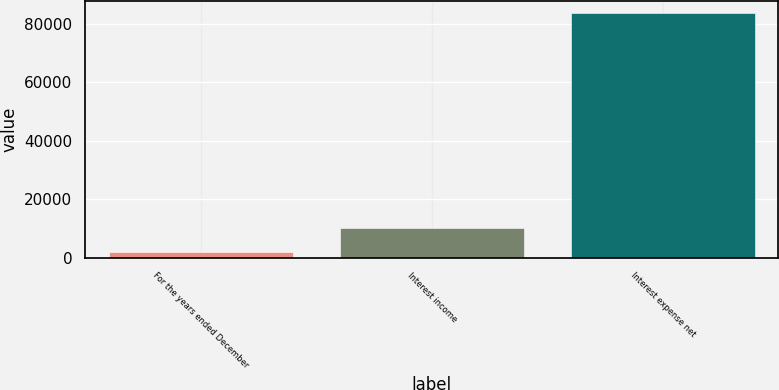Convert chart. <chart><loc_0><loc_0><loc_500><loc_500><bar_chart><fcel>For the years ended December<fcel>Interest income<fcel>Interest expense net<nl><fcel>2014<fcel>10165.8<fcel>83532<nl></chart> 